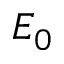Convert formula to latex. <formula><loc_0><loc_0><loc_500><loc_500>E _ { 0 }</formula> 